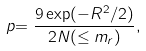<formula> <loc_0><loc_0><loc_500><loc_500>p { = \frac { 9 \exp ( - R ^ { 2 } / 2 ) } { 2 N ( \leq m _ { r } ) } } ,</formula> 